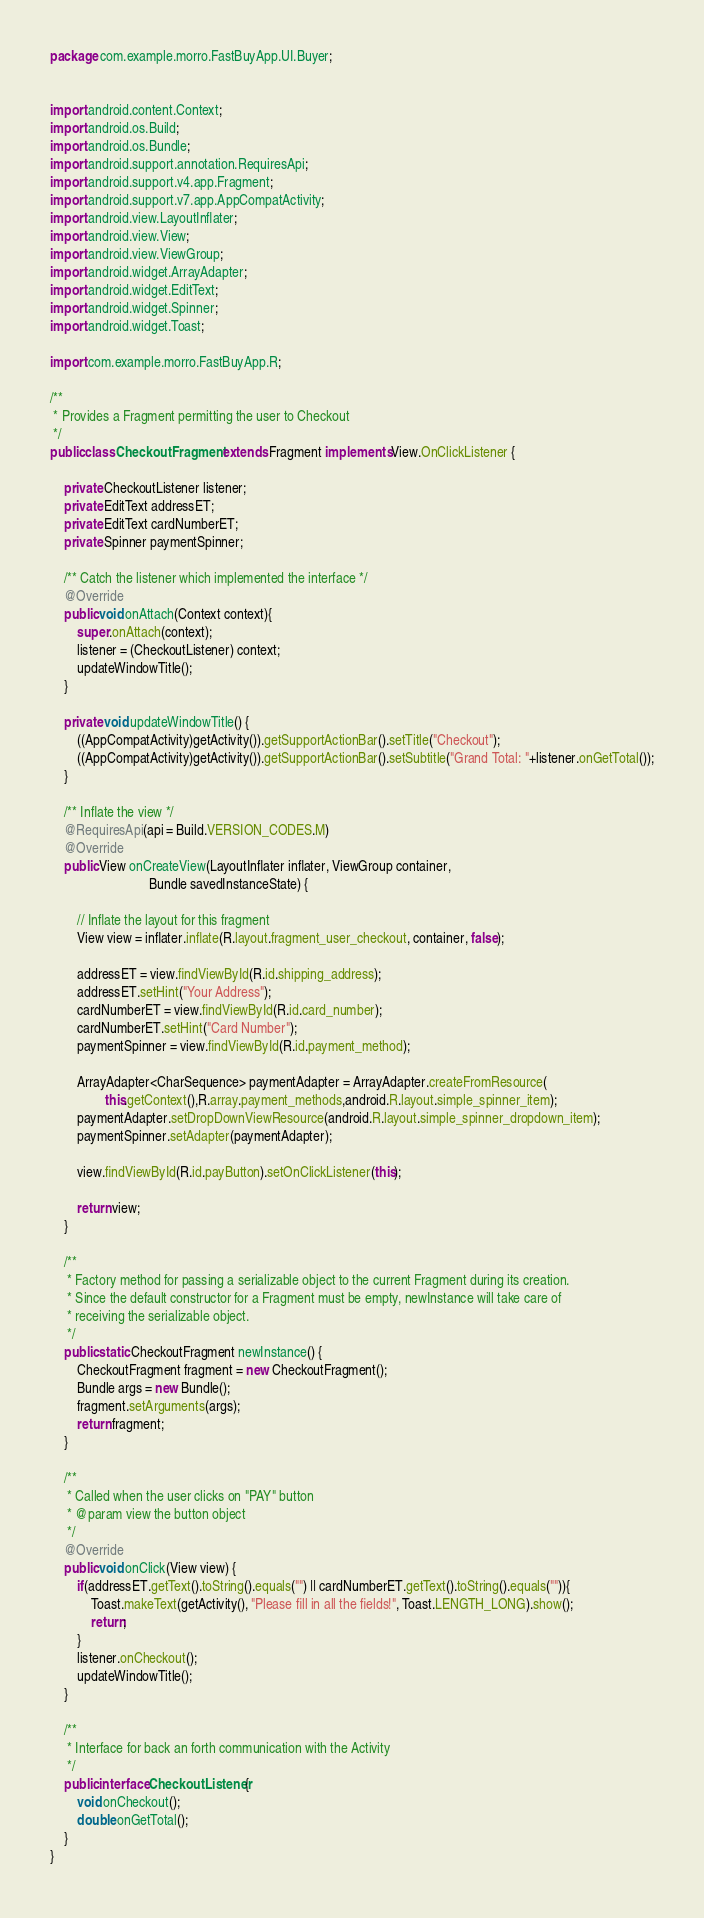<code> <loc_0><loc_0><loc_500><loc_500><_Java_>package com.example.morro.FastBuyApp.UI.Buyer;


import android.content.Context;
import android.os.Build;
import android.os.Bundle;
import android.support.annotation.RequiresApi;
import android.support.v4.app.Fragment;
import android.support.v7.app.AppCompatActivity;
import android.view.LayoutInflater;
import android.view.View;
import android.view.ViewGroup;
import android.widget.ArrayAdapter;
import android.widget.EditText;
import android.widget.Spinner;
import android.widget.Toast;

import com.example.morro.FastBuyApp.R;

/**
 * Provides a Fragment permitting the user to Checkout
 */
public class CheckoutFragment extends Fragment implements View.OnClickListener {

    private CheckoutListener listener;
    private EditText addressET;
    private EditText cardNumberET;
    private Spinner paymentSpinner;

    /** Catch the listener which implemented the interface */
    @Override
    public void onAttach(Context context){
        super.onAttach(context);
        listener = (CheckoutListener) context;
        updateWindowTitle();
    }

    private void updateWindowTitle() {
        ((AppCompatActivity)getActivity()).getSupportActionBar().setTitle("Checkout");
        ((AppCompatActivity)getActivity()).getSupportActionBar().setSubtitle("Grand Total: "+listener.onGetTotal());
    }

    /** Inflate the view */
    @RequiresApi(api = Build.VERSION_CODES.M)
    @Override
    public View onCreateView(LayoutInflater inflater, ViewGroup container,
                             Bundle savedInstanceState) {

        // Inflate the layout for this fragment
        View view = inflater.inflate(R.layout.fragment_user_checkout, container, false);

        addressET = view.findViewById(R.id.shipping_address);
        addressET.setHint("Your Address");
        cardNumberET = view.findViewById(R.id.card_number);
        cardNumberET.setHint("Card Number");
        paymentSpinner = view.findViewById(R.id.payment_method);

        ArrayAdapter<CharSequence> paymentAdapter = ArrayAdapter.createFromResource(
                this.getContext(),R.array.payment_methods,android.R.layout.simple_spinner_item);
        paymentAdapter.setDropDownViewResource(android.R.layout.simple_spinner_dropdown_item);
        paymentSpinner.setAdapter(paymentAdapter);

        view.findViewById(R.id.payButton).setOnClickListener(this);

        return view;
    }

    /**
     * Factory method for passing a serializable object to the current Fragment during its creation.
     * Since the default constructor for a Fragment must be empty, newInstance will take care of
     * receiving the serializable object.
     */
    public static CheckoutFragment newInstance() {
        CheckoutFragment fragment = new CheckoutFragment();
        Bundle args = new Bundle();
        fragment.setArguments(args);
        return fragment;
    }

    /**
     * Called when the user clicks on "PAY" button
     * @param view the button object
     */
    @Override
    public void onClick(View view) {
        if(addressET.getText().toString().equals("") || cardNumberET.getText().toString().equals("")){
            Toast.makeText(getActivity(), "Please fill in all the fields!", Toast.LENGTH_LONG).show();
            return;
        }
        listener.onCheckout();
        updateWindowTitle();
    }

    /**
     * Interface for back an forth communication with the Activity
     */
    public interface CheckoutListener{
        void onCheckout();
        double onGetTotal();
    }
}
</code> 